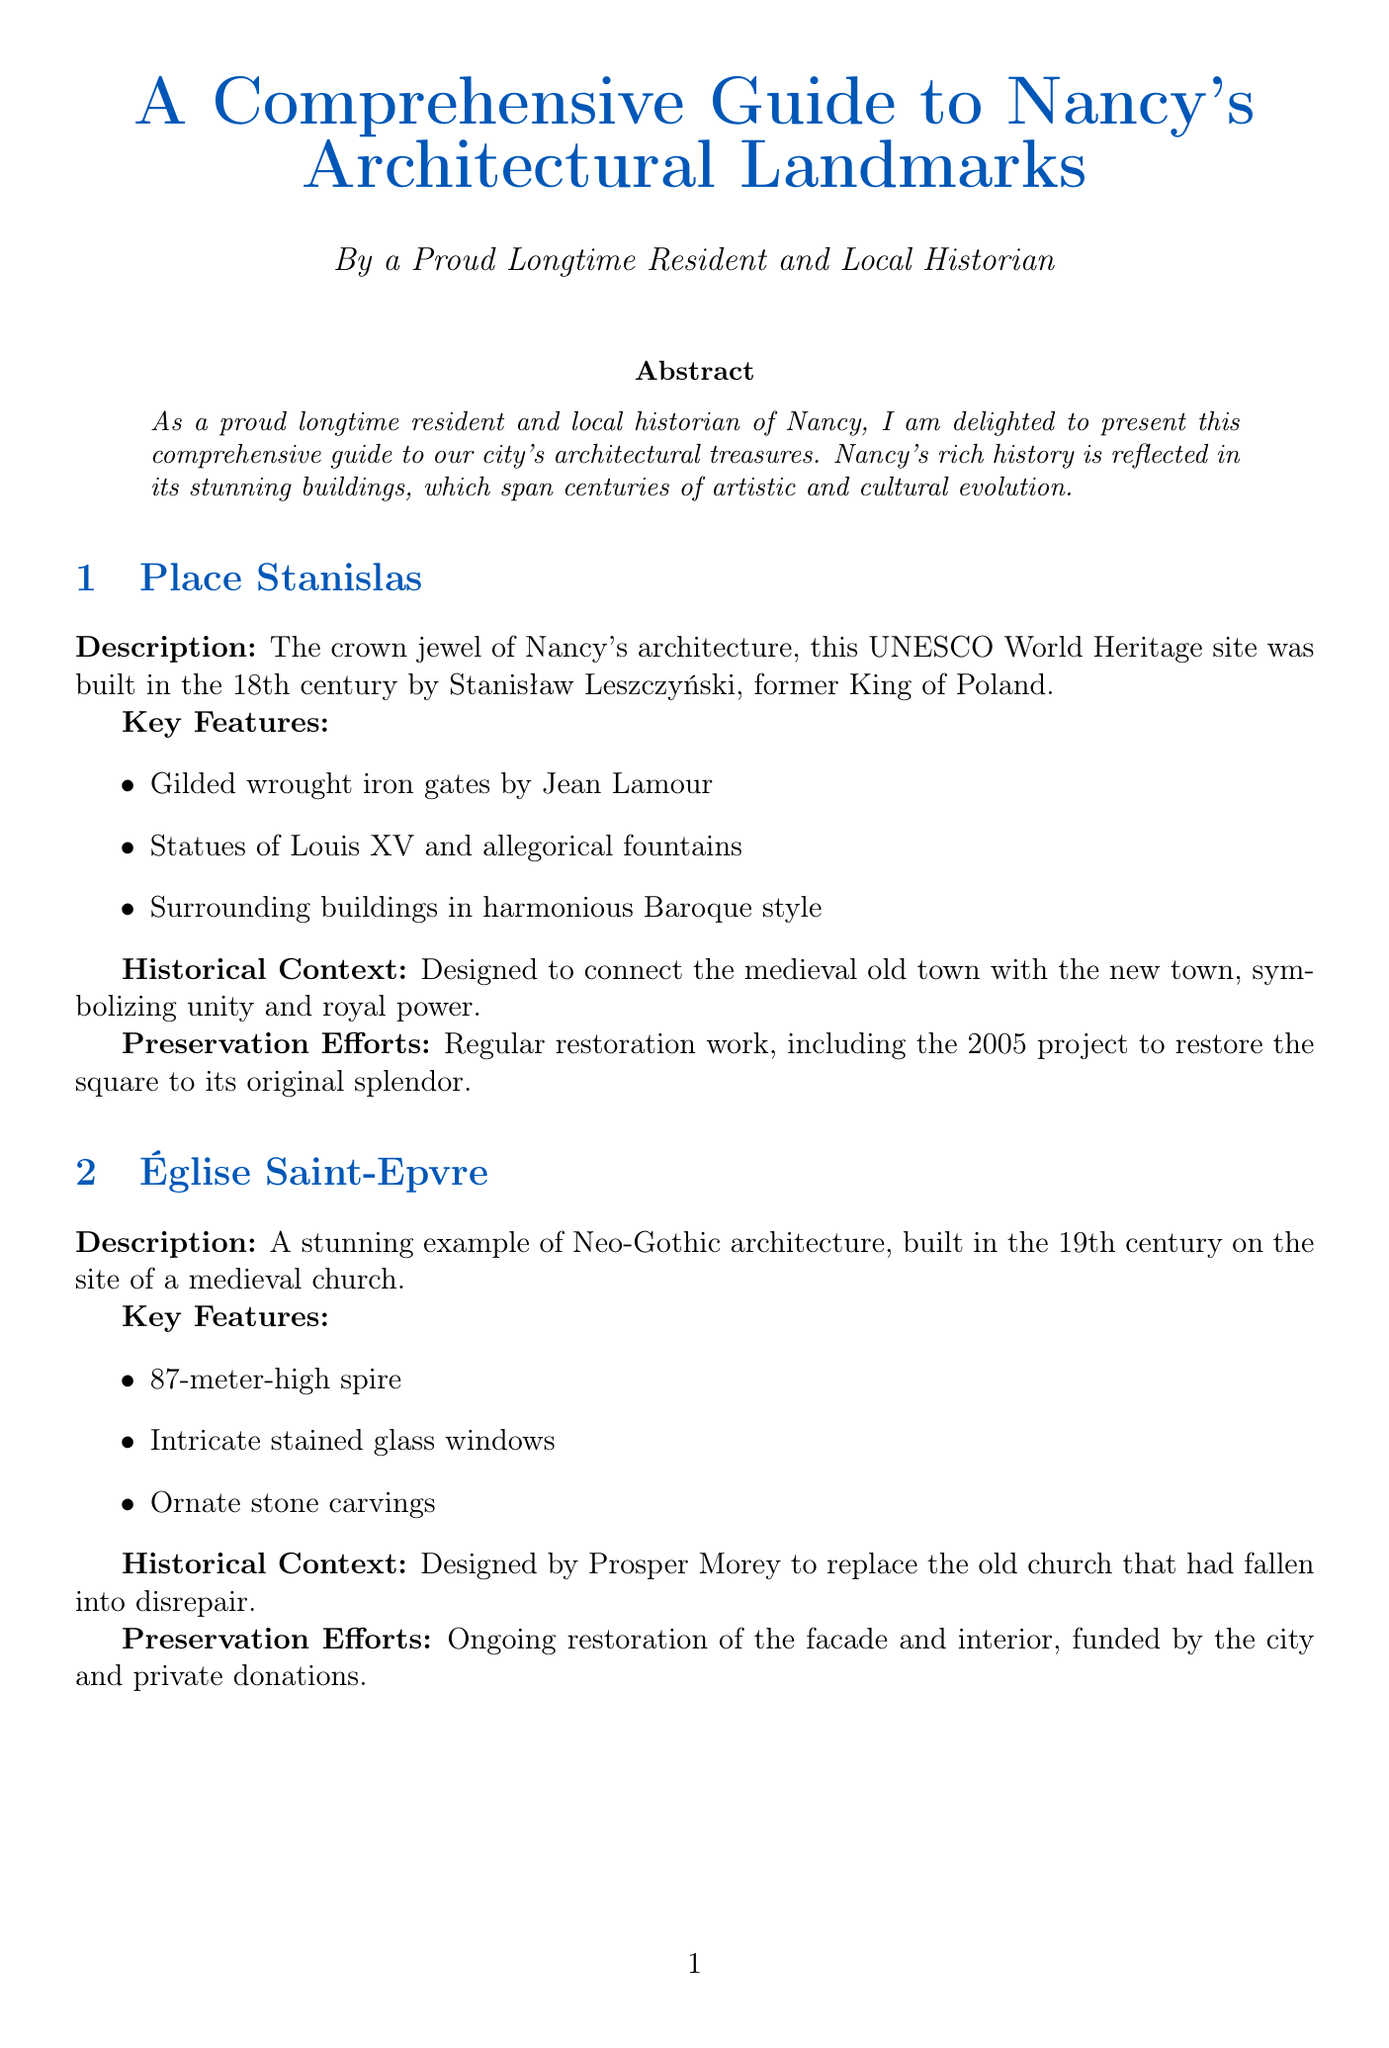What is the crown jewel of Nancy's architecture? Place Stanislas is described as the crown jewel of Nancy's architecture in the document.
Answer: Place Stanislas Who designed the Villa Majorelle? The document states that the Villa Majorelle was designed by Henri Sauvage.
Answer: Henri Sauvage What year was the extensive restoration of the Villa Majorelle completed? The document mentions that the extensive restoration of the Villa Majorelle was completed in 2020.
Answer: 2020 Which government body oversees the protection of historical monuments in the region? The Direction Régionale des Affaires Culturelles Grand Est is the government body that oversees the protection of historical monuments.
Answer: Direction Régionale des Affaires Culturelles Grand Est What architectural style is the Église Saint-Epvre? The Église Saint-Epvre is described as a stunning example of Neo-Gothic architecture in the document.
Answer: Neo-Gothic What type of restoration efforts are ongoing for the Église Saint-Epvre? The document states that there is ongoing restoration of the facade and interior of the Église Saint-Epvre.
Answer: Ongoing restoration How high is the spire of the Église Saint-Epvre? The document specifies that the spire of the Église Saint-Epvre is 87 meters high.
Answer: 87 meters What is the focus of the fundraising initiatives by the Association Nancy Renaissance? The Association Nancy Renaissance focuses on fundraising for restoration projects as one of its key initiatives.
Answer: Fundraising for restoration projects What does the Nancy Historical Center Map highlight? The Nancy Historical Center Map highlights key architectural landmarks in Nancy's UNESCO-listed city center.
Answer: Key architectural landmarks 